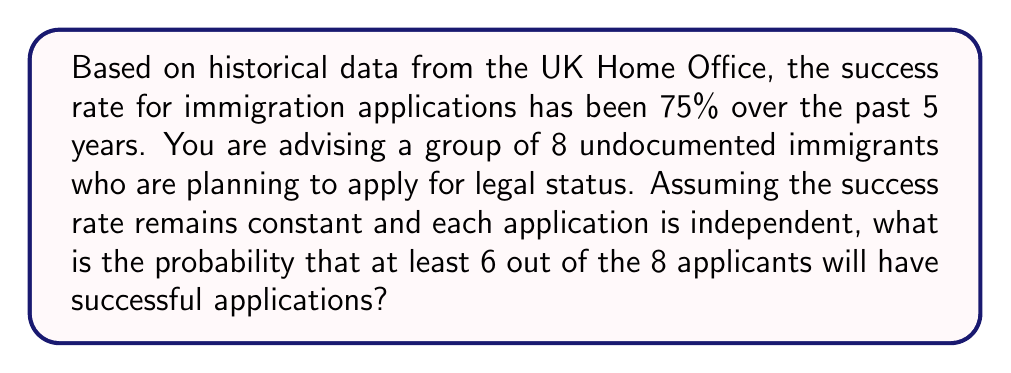Solve this math problem. To solve this problem, we'll use the binomial probability distribution, as we're dealing with a fixed number of independent trials (applications) with two possible outcomes (success or failure) for each trial.

Let's define our variables:
$n = 8$ (total number of applicants)
$p = 0.75$ (probability of success for each application)
$q = 1 - p = 0.25$ (probability of failure for each application)

We want to find the probability of at least 6 successes, which means we need to calculate the probability of 6, 7, or 8 successes and sum them up.

The probability mass function for a binomial distribution is:

$$P(X = k) = \binom{n}{k} p^k q^{n-k}$$

Where $\binom{n}{k}$ is the binomial coefficient, calculated as:

$$\binom{n}{k} = \frac{n!}{k!(n-k)!}$$

Let's calculate the probability for each case:

For 6 successes:
$$P(X = 6) = \binom{8}{6} (0.75)^6 (0.25)^2 = 28 \times 0.177978516 \times 0.0625 = 0.3111$$

For 7 successes:
$$P(X = 7) = \binom{8}{7} (0.75)^7 (0.25)^1 = 8 \times 0.133483887 \times 0.25 = 0.2670$$

For 8 successes:
$$P(X = 8) = \binom{8}{8} (0.75)^8 (0.25)^0 = 1 \times 0.100112915 \times 1 = 0.1001$$

Now, we sum these probabilities to get the probability of at least 6 successes:

$$P(X \geq 6) = P(X = 6) + P(X = 7) + P(X = 8) = 0.3111 + 0.2670 + 0.1001 = 0.6782$$

Therefore, the probability that at least 6 out of the 8 applicants will have successful applications is approximately 0.6782 or 67.82%.
Answer: 0.6782 or 67.82% 